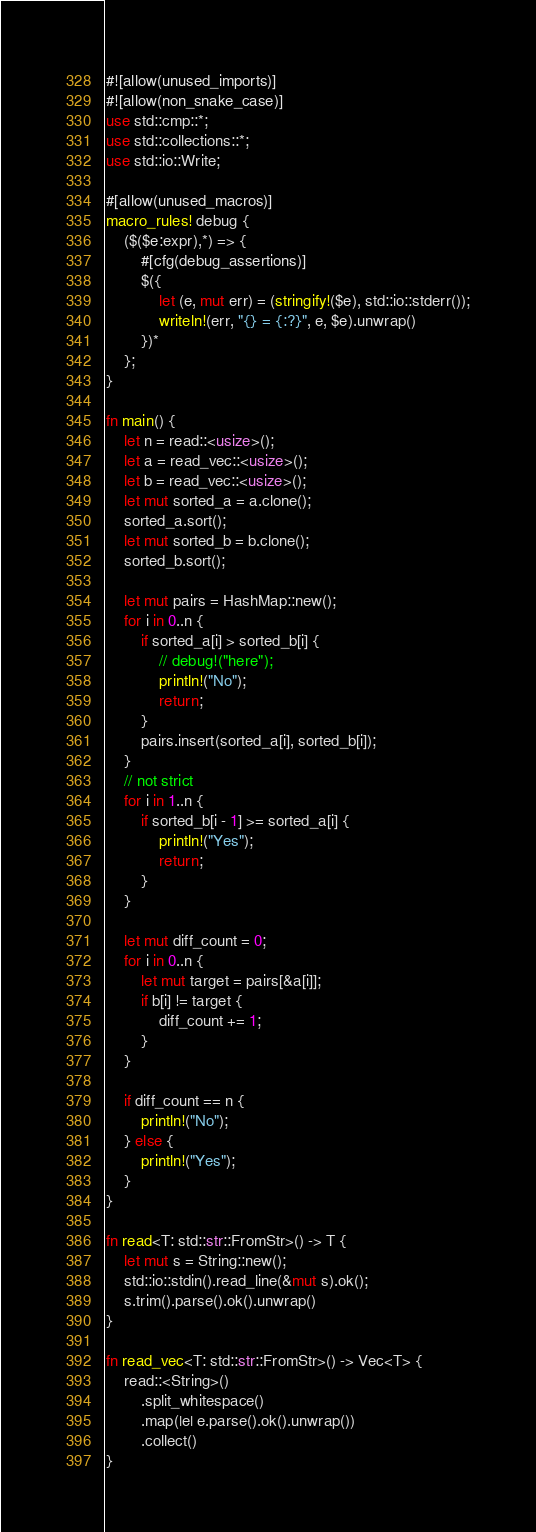Convert code to text. <code><loc_0><loc_0><loc_500><loc_500><_Rust_>#![allow(unused_imports)]
#![allow(non_snake_case)]
use std::cmp::*;
use std::collections::*;
use std::io::Write;

#[allow(unused_macros)]
macro_rules! debug {
    ($($e:expr),*) => {
        #[cfg(debug_assertions)]
        $({
            let (e, mut err) = (stringify!($e), std::io::stderr());
            writeln!(err, "{} = {:?}", e, $e).unwrap()
        })*
    };
}

fn main() {
    let n = read::<usize>();
    let a = read_vec::<usize>();
    let b = read_vec::<usize>();
    let mut sorted_a = a.clone();
    sorted_a.sort();
    let mut sorted_b = b.clone();
    sorted_b.sort();

    let mut pairs = HashMap::new();
    for i in 0..n {
        if sorted_a[i] > sorted_b[i] {
            // debug!("here");
            println!("No");
            return;
        }
        pairs.insert(sorted_a[i], sorted_b[i]);
    }
    // not strict
    for i in 1..n {
        if sorted_b[i - 1] >= sorted_a[i] {
            println!("Yes");
            return;
        }
    }

    let mut diff_count = 0;
    for i in 0..n {
        let mut target = pairs[&a[i]];
        if b[i] != target {
            diff_count += 1;
        }
    }

    if diff_count == n {
        println!("No");
    } else {
        println!("Yes");
    }
}

fn read<T: std::str::FromStr>() -> T {
    let mut s = String::new();
    std::io::stdin().read_line(&mut s).ok();
    s.trim().parse().ok().unwrap()
}

fn read_vec<T: std::str::FromStr>() -> Vec<T> {
    read::<String>()
        .split_whitespace()
        .map(|e| e.parse().ok().unwrap())
        .collect()
}
</code> 